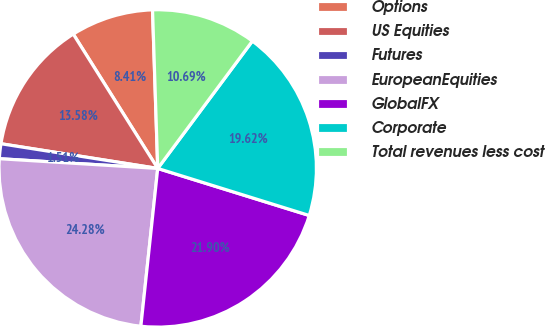Convert chart to OTSL. <chart><loc_0><loc_0><loc_500><loc_500><pie_chart><fcel>Options<fcel>US Equities<fcel>Futures<fcel>EuropeanEquities<fcel>GlobalFX<fcel>Corporate<fcel>Total revenues less cost<nl><fcel>8.41%<fcel>13.58%<fcel>1.51%<fcel>24.28%<fcel>21.9%<fcel>19.62%<fcel>10.69%<nl></chart> 